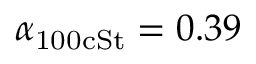<formula> <loc_0><loc_0><loc_500><loc_500>\alpha _ { 1 0 0 c S t } = 0 . 3 9</formula> 